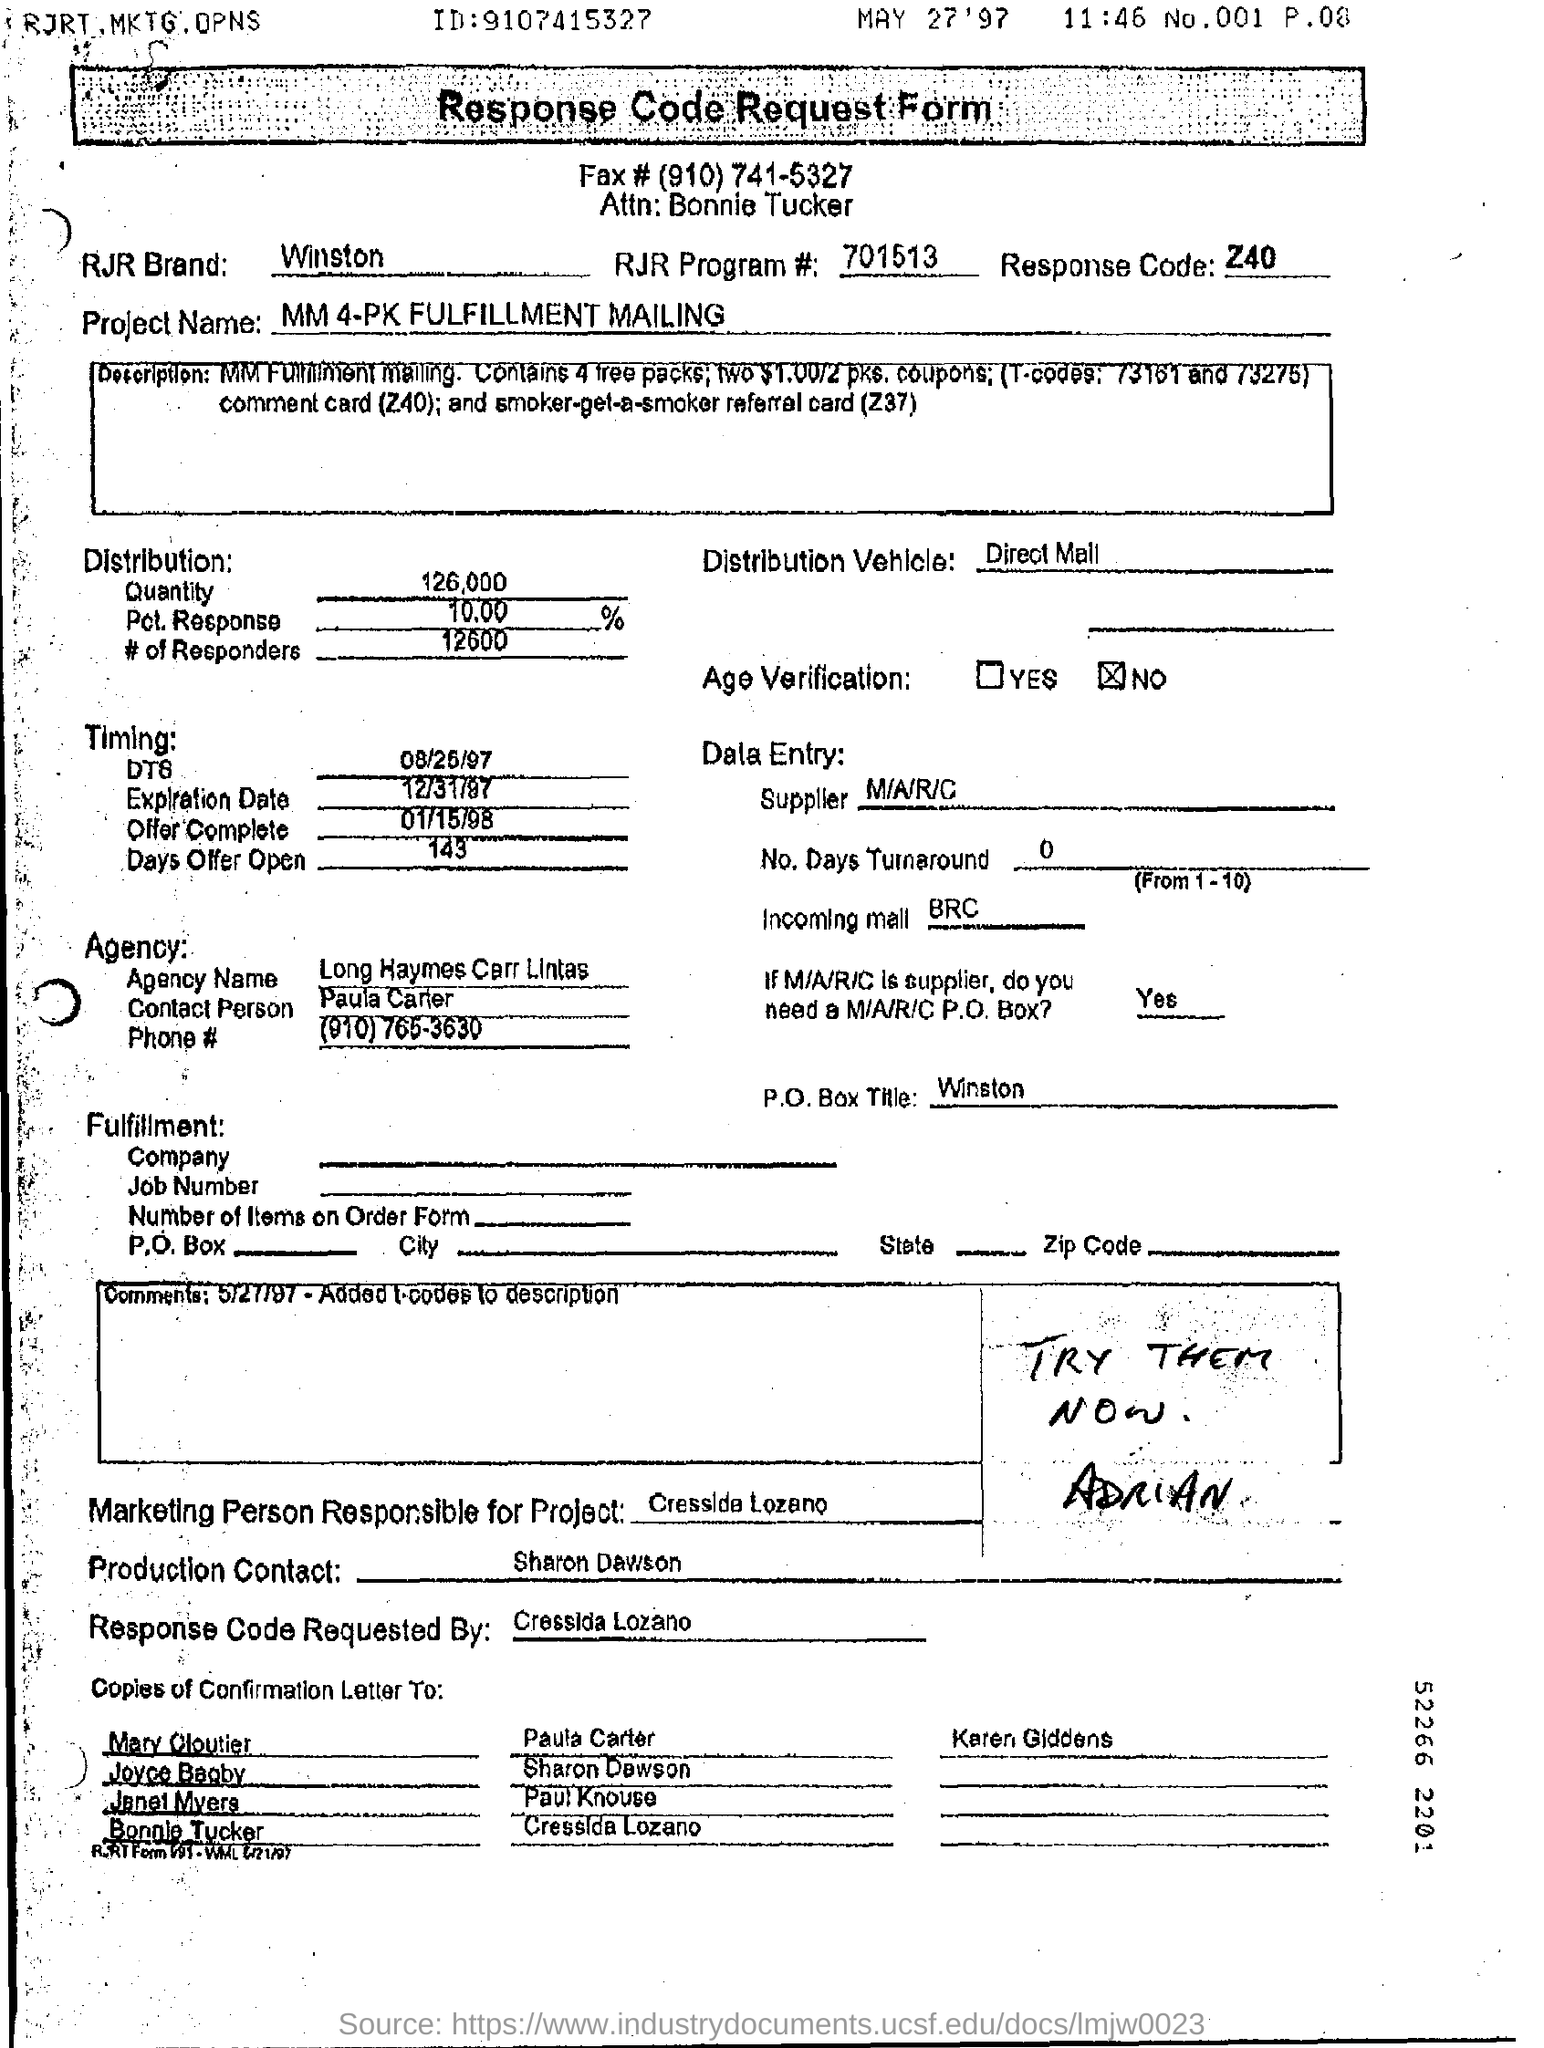What is the agency name ?
Provide a short and direct response. Long HAymes Carr Lintas. What is p .o. box title ?
Keep it short and to the point. Winston. What is the distribution vehicle ?
Ensure brevity in your answer.  Direct Mail. 